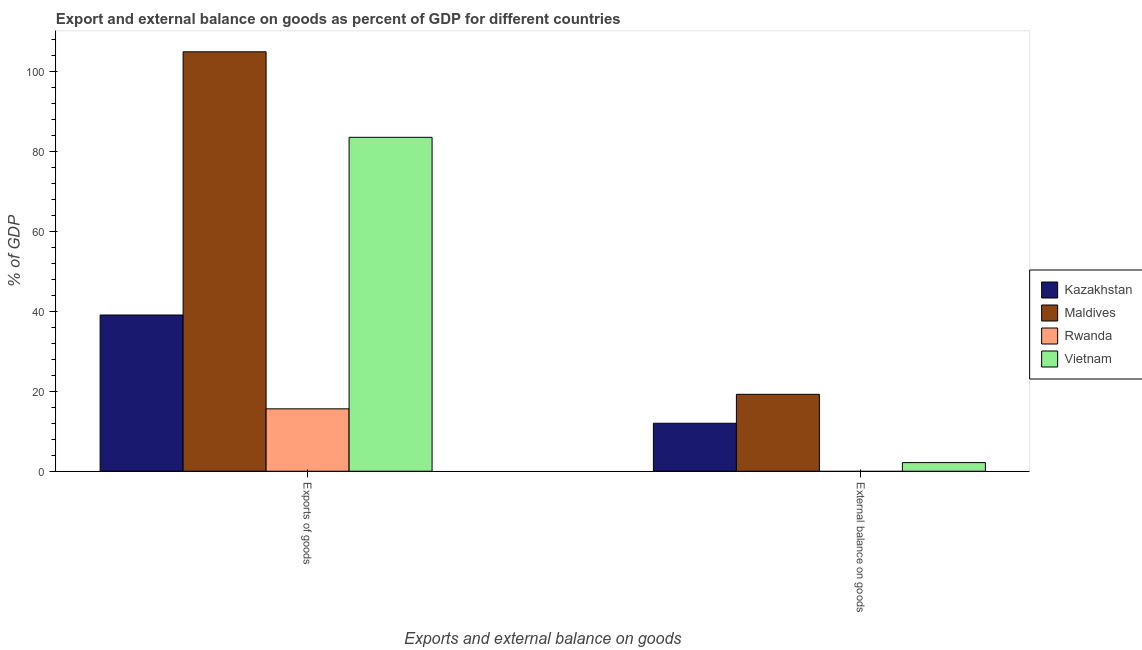How many different coloured bars are there?
Your answer should be compact. 4. How many groups of bars are there?
Give a very brief answer. 2. Are the number of bars per tick equal to the number of legend labels?
Give a very brief answer. No. How many bars are there on the 2nd tick from the left?
Ensure brevity in your answer.  3. How many bars are there on the 1st tick from the right?
Offer a terse response. 3. What is the label of the 2nd group of bars from the left?
Provide a short and direct response. External balance on goods. What is the export of goods as percentage of gdp in Kazakhstan?
Your response must be concise. 39.12. Across all countries, what is the maximum export of goods as percentage of gdp?
Give a very brief answer. 105.05. Across all countries, what is the minimum export of goods as percentage of gdp?
Offer a terse response. 15.62. In which country was the export of goods as percentage of gdp maximum?
Your response must be concise. Maldives. What is the total external balance on goods as percentage of gdp in the graph?
Provide a succinct answer. 33.43. What is the difference between the export of goods as percentage of gdp in Maldives and that in Rwanda?
Provide a succinct answer. 89.42. What is the difference between the external balance on goods as percentage of gdp in Vietnam and the export of goods as percentage of gdp in Rwanda?
Your answer should be very brief. -13.47. What is the average external balance on goods as percentage of gdp per country?
Your answer should be very brief. 8.36. What is the difference between the external balance on goods as percentage of gdp and export of goods as percentage of gdp in Kazakhstan?
Keep it short and to the point. -27.11. In how many countries, is the export of goods as percentage of gdp greater than 52 %?
Your answer should be compact. 2. What is the ratio of the external balance on goods as percentage of gdp in Vietnam to that in Maldives?
Offer a terse response. 0.11. In how many countries, is the external balance on goods as percentage of gdp greater than the average external balance on goods as percentage of gdp taken over all countries?
Ensure brevity in your answer.  2. How many bars are there?
Make the answer very short. 7. What is the difference between two consecutive major ticks on the Y-axis?
Your answer should be very brief. 20. Are the values on the major ticks of Y-axis written in scientific E-notation?
Keep it short and to the point. No. How many legend labels are there?
Give a very brief answer. 4. How are the legend labels stacked?
Offer a very short reply. Vertical. What is the title of the graph?
Offer a very short reply. Export and external balance on goods as percent of GDP for different countries. Does "Arab World" appear as one of the legend labels in the graph?
Provide a succinct answer. No. What is the label or title of the X-axis?
Provide a short and direct response. Exports and external balance on goods. What is the label or title of the Y-axis?
Keep it short and to the point. % of GDP. What is the % of GDP in Kazakhstan in Exports of goods?
Offer a terse response. 39.12. What is the % of GDP of Maldives in Exports of goods?
Your answer should be very brief. 105.05. What is the % of GDP of Rwanda in Exports of goods?
Give a very brief answer. 15.62. What is the % of GDP in Vietnam in Exports of goods?
Provide a succinct answer. 83.63. What is the % of GDP of Kazakhstan in External balance on goods?
Your response must be concise. 12.01. What is the % of GDP in Maldives in External balance on goods?
Provide a short and direct response. 19.26. What is the % of GDP in Vietnam in External balance on goods?
Your answer should be compact. 2.16. Across all Exports and external balance on goods, what is the maximum % of GDP in Kazakhstan?
Offer a terse response. 39.12. Across all Exports and external balance on goods, what is the maximum % of GDP of Maldives?
Keep it short and to the point. 105.05. Across all Exports and external balance on goods, what is the maximum % of GDP in Rwanda?
Provide a succinct answer. 15.62. Across all Exports and external balance on goods, what is the maximum % of GDP of Vietnam?
Give a very brief answer. 83.63. Across all Exports and external balance on goods, what is the minimum % of GDP in Kazakhstan?
Offer a terse response. 12.01. Across all Exports and external balance on goods, what is the minimum % of GDP of Maldives?
Ensure brevity in your answer.  19.26. Across all Exports and external balance on goods, what is the minimum % of GDP in Vietnam?
Offer a very short reply. 2.16. What is the total % of GDP in Kazakhstan in the graph?
Ensure brevity in your answer.  51.14. What is the total % of GDP of Maldives in the graph?
Provide a short and direct response. 124.31. What is the total % of GDP of Rwanda in the graph?
Your answer should be very brief. 15.62. What is the total % of GDP in Vietnam in the graph?
Your answer should be very brief. 85.78. What is the difference between the % of GDP in Kazakhstan in Exports of goods and that in External balance on goods?
Your answer should be very brief. 27.11. What is the difference between the % of GDP in Maldives in Exports of goods and that in External balance on goods?
Make the answer very short. 85.78. What is the difference between the % of GDP in Vietnam in Exports of goods and that in External balance on goods?
Offer a very short reply. 81.47. What is the difference between the % of GDP of Kazakhstan in Exports of goods and the % of GDP of Maldives in External balance on goods?
Your answer should be compact. 19.86. What is the difference between the % of GDP in Kazakhstan in Exports of goods and the % of GDP in Vietnam in External balance on goods?
Your answer should be compact. 36.97. What is the difference between the % of GDP in Maldives in Exports of goods and the % of GDP in Vietnam in External balance on goods?
Your answer should be very brief. 102.89. What is the difference between the % of GDP in Rwanda in Exports of goods and the % of GDP in Vietnam in External balance on goods?
Provide a succinct answer. 13.47. What is the average % of GDP of Kazakhstan per Exports and external balance on goods?
Provide a short and direct response. 25.57. What is the average % of GDP of Maldives per Exports and external balance on goods?
Provide a succinct answer. 62.15. What is the average % of GDP in Rwanda per Exports and external balance on goods?
Offer a very short reply. 7.81. What is the average % of GDP in Vietnam per Exports and external balance on goods?
Your answer should be compact. 42.89. What is the difference between the % of GDP in Kazakhstan and % of GDP in Maldives in Exports of goods?
Give a very brief answer. -65.92. What is the difference between the % of GDP of Kazakhstan and % of GDP of Rwanda in Exports of goods?
Your answer should be very brief. 23.5. What is the difference between the % of GDP of Kazakhstan and % of GDP of Vietnam in Exports of goods?
Provide a short and direct response. -44.5. What is the difference between the % of GDP of Maldives and % of GDP of Rwanda in Exports of goods?
Offer a very short reply. 89.42. What is the difference between the % of GDP of Maldives and % of GDP of Vietnam in Exports of goods?
Offer a very short reply. 21.42. What is the difference between the % of GDP in Rwanda and % of GDP in Vietnam in Exports of goods?
Offer a very short reply. -68. What is the difference between the % of GDP in Kazakhstan and % of GDP in Maldives in External balance on goods?
Keep it short and to the point. -7.25. What is the difference between the % of GDP in Kazakhstan and % of GDP in Vietnam in External balance on goods?
Ensure brevity in your answer.  9.86. What is the difference between the % of GDP of Maldives and % of GDP of Vietnam in External balance on goods?
Keep it short and to the point. 17.1. What is the ratio of the % of GDP in Kazakhstan in Exports of goods to that in External balance on goods?
Give a very brief answer. 3.26. What is the ratio of the % of GDP in Maldives in Exports of goods to that in External balance on goods?
Offer a terse response. 5.45. What is the ratio of the % of GDP in Vietnam in Exports of goods to that in External balance on goods?
Your response must be concise. 38.75. What is the difference between the highest and the second highest % of GDP of Kazakhstan?
Your answer should be very brief. 27.11. What is the difference between the highest and the second highest % of GDP in Maldives?
Ensure brevity in your answer.  85.78. What is the difference between the highest and the second highest % of GDP of Vietnam?
Your answer should be compact. 81.47. What is the difference between the highest and the lowest % of GDP in Kazakhstan?
Your answer should be very brief. 27.11. What is the difference between the highest and the lowest % of GDP of Maldives?
Offer a terse response. 85.78. What is the difference between the highest and the lowest % of GDP in Rwanda?
Ensure brevity in your answer.  15.62. What is the difference between the highest and the lowest % of GDP of Vietnam?
Ensure brevity in your answer.  81.47. 